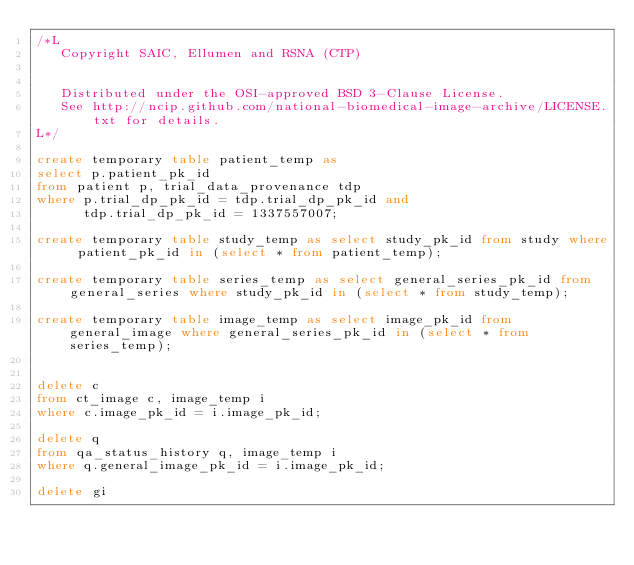<code> <loc_0><loc_0><loc_500><loc_500><_SQL_>/*L
   Copyright SAIC, Ellumen and RSNA (CTP)


   Distributed under the OSI-approved BSD 3-Clause License.
   See http://ncip.github.com/national-biomedical-image-archive/LICENSE.txt for details.
L*/

create temporary table patient_temp as 
select p.patient_pk_id
from patient p, trial_data_provenance tdp
where p.trial_dp_pk_id = tdp.trial_dp_pk_id and
      tdp.trial_dp_pk_id = 1337557007;
      
create temporary table study_temp as select study_pk_id from study where patient_pk_id in (select * from patient_temp);

create temporary table series_temp as select general_series_pk_id from general_series where study_pk_id in (select * from study_temp);

create temporary table image_temp as select image_pk_id from general_image where general_series_pk_id in (select * from series_temp);


delete c
from ct_image c, image_temp i
where c.image_pk_id = i.image_pk_id;

delete q
from qa_status_history q, image_temp i
where q.general_image_pk_id = i.image_pk_id;

delete gi</code> 